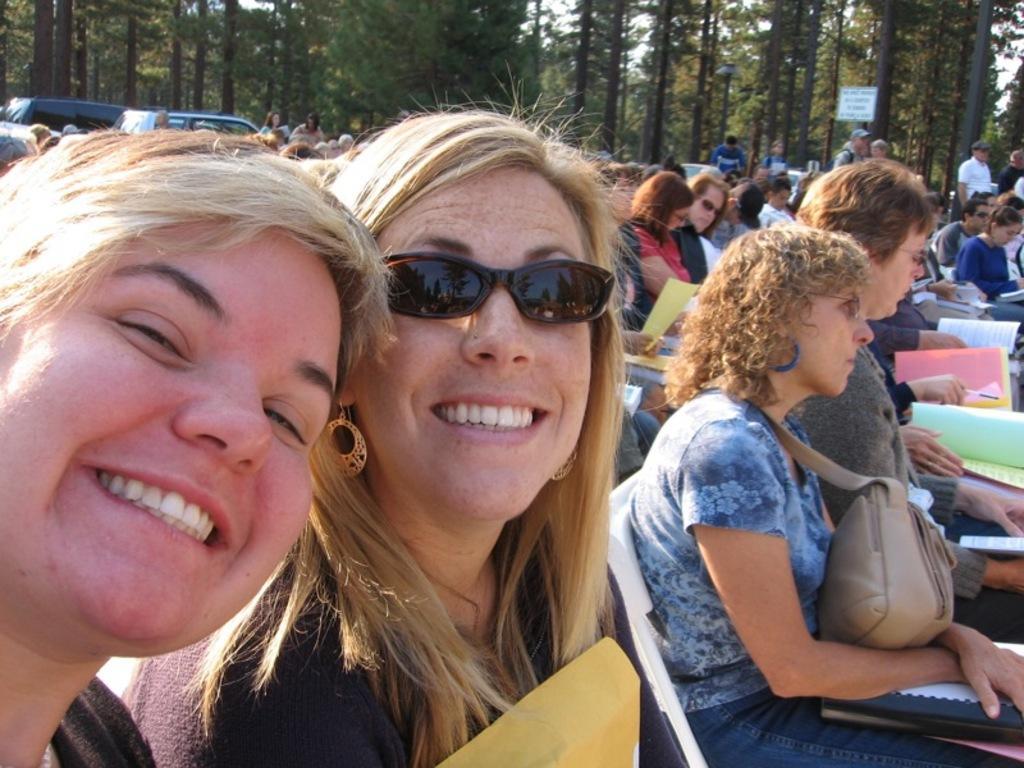Can you describe this image briefly? This image consists of so many persons. There are chairs and people are sitting on chairs. There are trees at the top. People are holding bags, files, books, papers. 